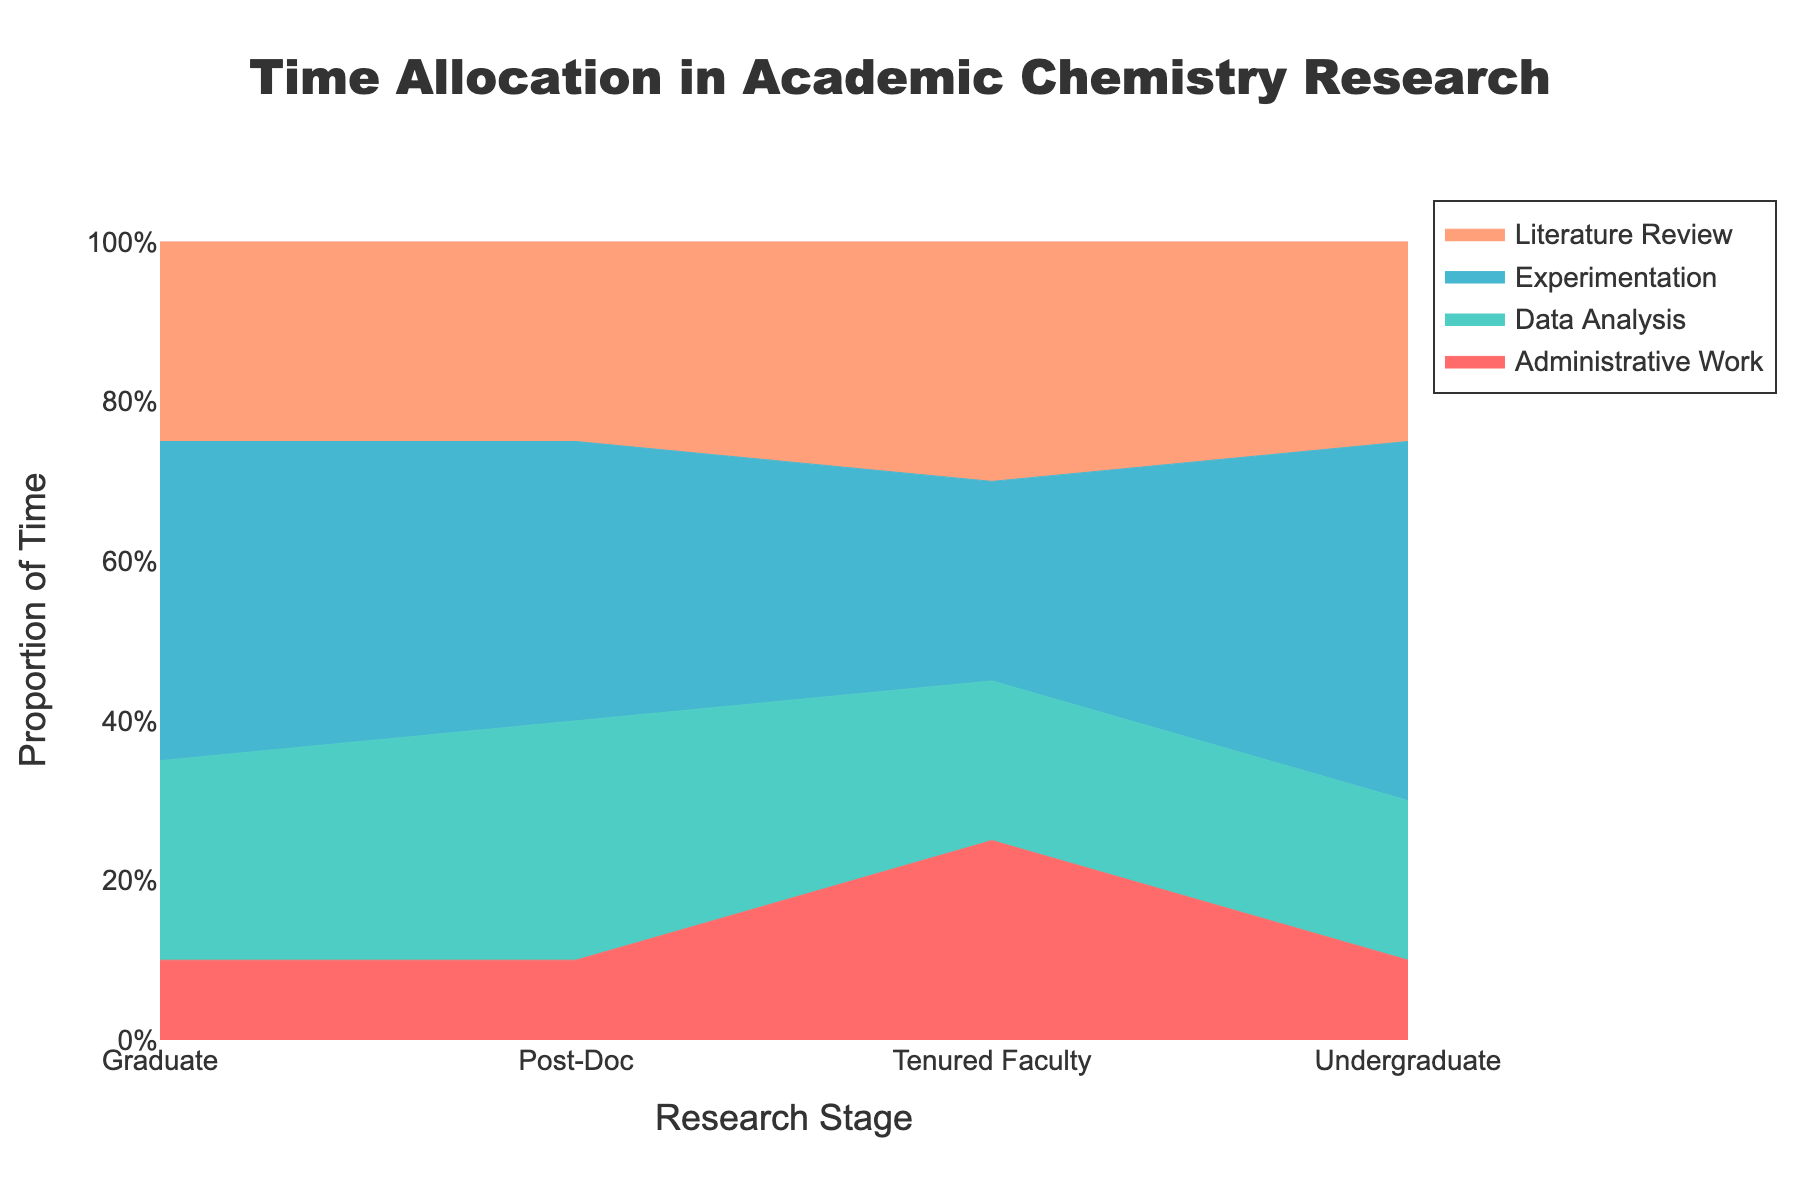Which research stage spends the highest proportion of time on experimentation? Look at the "Experimentation" area and compare its proportions for each research stage. Undergraduate stage spends the highest proportion of time on experimentation.
Answer: Undergraduate Which research stage allocates the least time to administrative work? Examine the "Administrative Work" area for all stages and find the lowest proportion. All stages have administrative work at 10%, except for Tenured Faculty at 25%. Therefore, it is shared at all stages except Tenured Faculty.
Answer: Undergraduate, Graduate and Post-Doc How does the time spent on data analysis change from the undergraduate stage to the post-doc stage? Trace the "Data Analysis" area from the undergraduate stage to the post-doc stage. The proportion increases from 20% at the undergraduate stage to 30% at the post-doc stage.
Answer: Increases by 10% What is the total proportion of time spent on non-experimental tasks for tenured faculty? Sum the proportions of "Data Analysis," "Literature Review," and "Administrative Work" for Tenured Faculty. These are 20% + 30% + 25% = 75%.
Answer: 75% Is there any research stage where literature review surpasses experimentation in time allocation? Compare the "Literature Review" and "Experimentation" areas for each stage. Only at the Tenured Faculty stage, literature review (30%) surpasses experimentation (25%).
Answer: Yes, at the Tenured Faculty stage Which task sees the most significant proportional increase as researchers advance from undergraduate to tenured faculty? Compare the changes in proportions for all tasks from undergraduate to tenured faculty stages. Administrative work rises from 10% to 25%, while other tasks do not have such a significant increase.
Answer: Administrative Work How does the proportion of time spent on literature review for graduate researchers compare to that for tenured faculty? Look at the proportions for "Literature Review" for both stages. Graduate researchers spend 25%, and tenured faculty spend 30%, showing an increase.
Answer: Tenured Faculty spends 5% more What is the average proportion of time spent on experimentation across all research stages? Sum the proportions of "Experimentation" for all stages and divide by the number of stages. (45% + 40% + 35% + 25%) / 4 = 36.25%.
Answer: 36.25% If you combine the proportions of time spent on data analysis and literature review, which research stage spends the highest combined proportion of time on these tasks? Add the proportions of "Data Analysis" and "Literature Review" for each stage and compare them. Tenured Faculty: 20% + 30% = 50%, Post-Doc: 30% + 25% = 55%, Graduate: 25% + 25% = 50%, Undergraduate: 20% + 25% = 45%. Post-Doc has the highest combined proportion (55%).
Answer: Post-Doc 